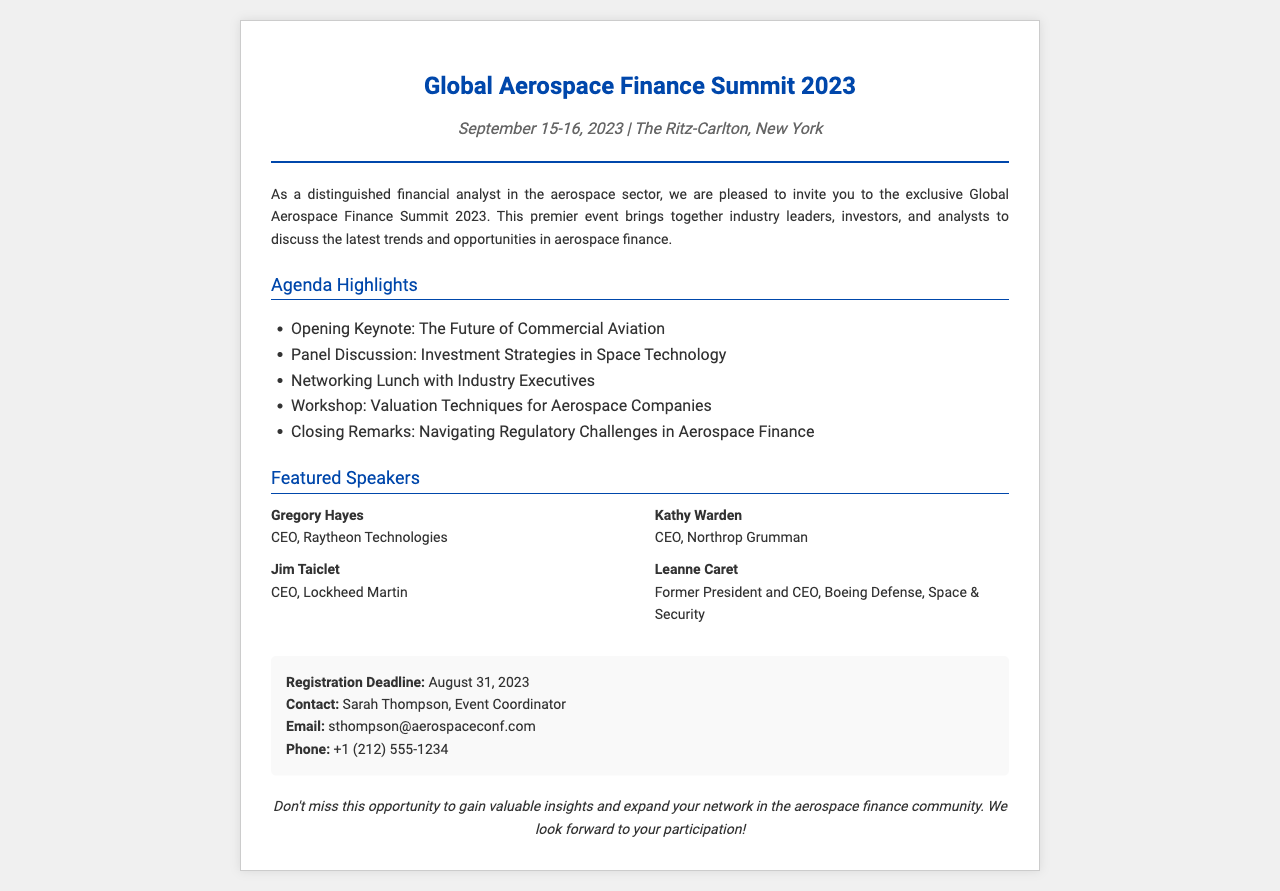What are the dates of the summit? The summit takes place on September 15-16, 2023, as mentioned in the document.
Answer: September 15-16, 2023 Where is the summit held? The location of the summit is specified in the document as The Ritz-Carlton, New York.
Answer: The Ritz-Carlton, New York Who is the keynote speaker? The opening keynote is focused on "The Future of Commercial Aviation," but the specific speaker is not named.
Answer: Not specified What is the registration deadline? The document states that the registration deadline is August 31, 2023.
Answer: August 31, 2023 Who is the contact person for registration? The contact person mentioned for registration is Sarah Thompson, Event Coordinator.
Answer: Sarah Thompson Which company does Gregory Hayes represent? The document lists Gregory Hayes as CEO of Raytheon Technologies.
Answer: Raytheon Technologies What type of event is being hosted? The document describes the event as the "Global Aerospace Finance Summit."
Answer: Global Aerospace Finance Summit What is one topic discussed in the agenda? The agenda includes a panel discussion on investment strategies in space technology.
Answer: Investment Strategies in Space Technology How many featured speakers are listed? There are four featured speakers mentioned in the document.
Answer: Four 